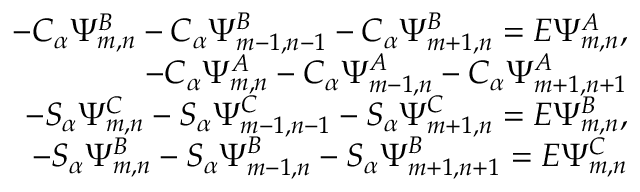Convert formula to latex. <formula><loc_0><loc_0><loc_500><loc_500>\begin{array} { r l r } & { - C _ { \alpha } \Psi _ { m , n } ^ { B } - C _ { \alpha } \Psi _ { m - 1 , n - 1 } ^ { B } - C _ { \alpha } \Psi _ { m + 1 , n } ^ { B } = E \Psi _ { m , n } ^ { A } , } \\ & { - C _ { \alpha } \Psi _ { m , n } ^ { A } - C _ { \alpha } \Psi _ { m - 1 , n } ^ { A } - C _ { \alpha } \Psi _ { m + 1 , n + 1 } ^ { A } } \\ & { - S _ { \alpha } \Psi _ { m , n } ^ { C } - S _ { \alpha } \Psi _ { m - 1 , n - 1 } ^ { C } - S _ { \alpha } \Psi _ { m + 1 , n } ^ { C } = E \Psi _ { m , n } ^ { B } , } \\ & { - S _ { \alpha } \Psi _ { m , n } ^ { B } - S _ { \alpha } \Psi _ { m - 1 , n } ^ { B } - S _ { \alpha } \Psi _ { m + 1 , n + 1 } ^ { B } = E \Psi _ { m , n } ^ { C } } \end{array}</formula> 